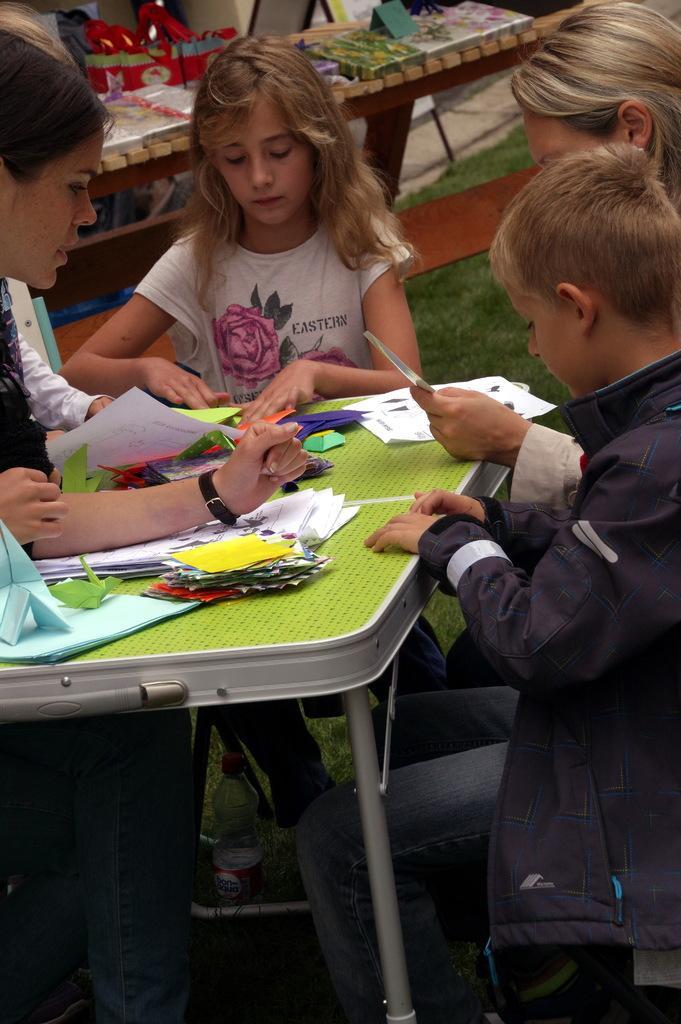Can you describe this image briefly? There are some persons sitting as we can see in the middle of this image. There are some papers kept on a table at the bottom of this image, and there are some objects are kept on an other table at the top of this image. 